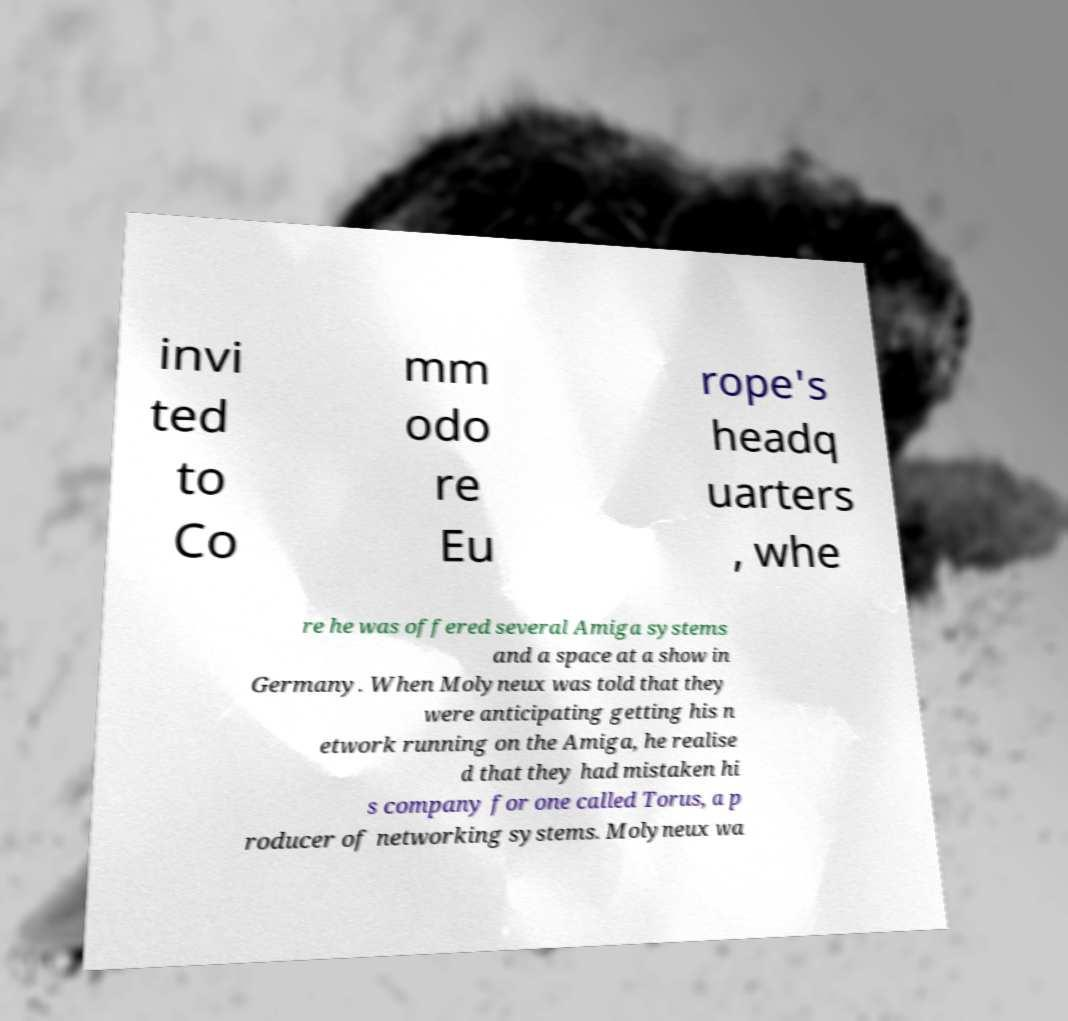Please identify and transcribe the text found in this image. invi ted to Co mm odo re Eu rope's headq uarters , whe re he was offered several Amiga systems and a space at a show in Germany. When Molyneux was told that they were anticipating getting his n etwork running on the Amiga, he realise d that they had mistaken hi s company for one called Torus, a p roducer of networking systems. Molyneux wa 